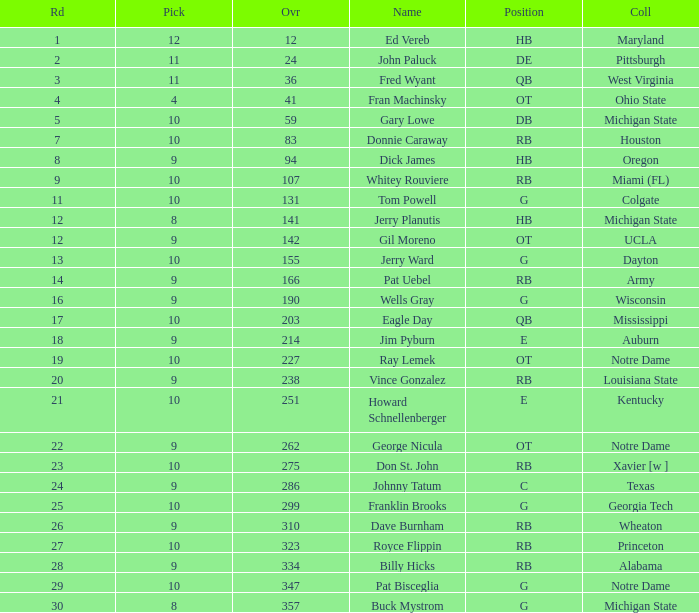What is the overall pick number for a draft pick smaller than 9, named buck mystrom from Michigan State college? 357.0. 